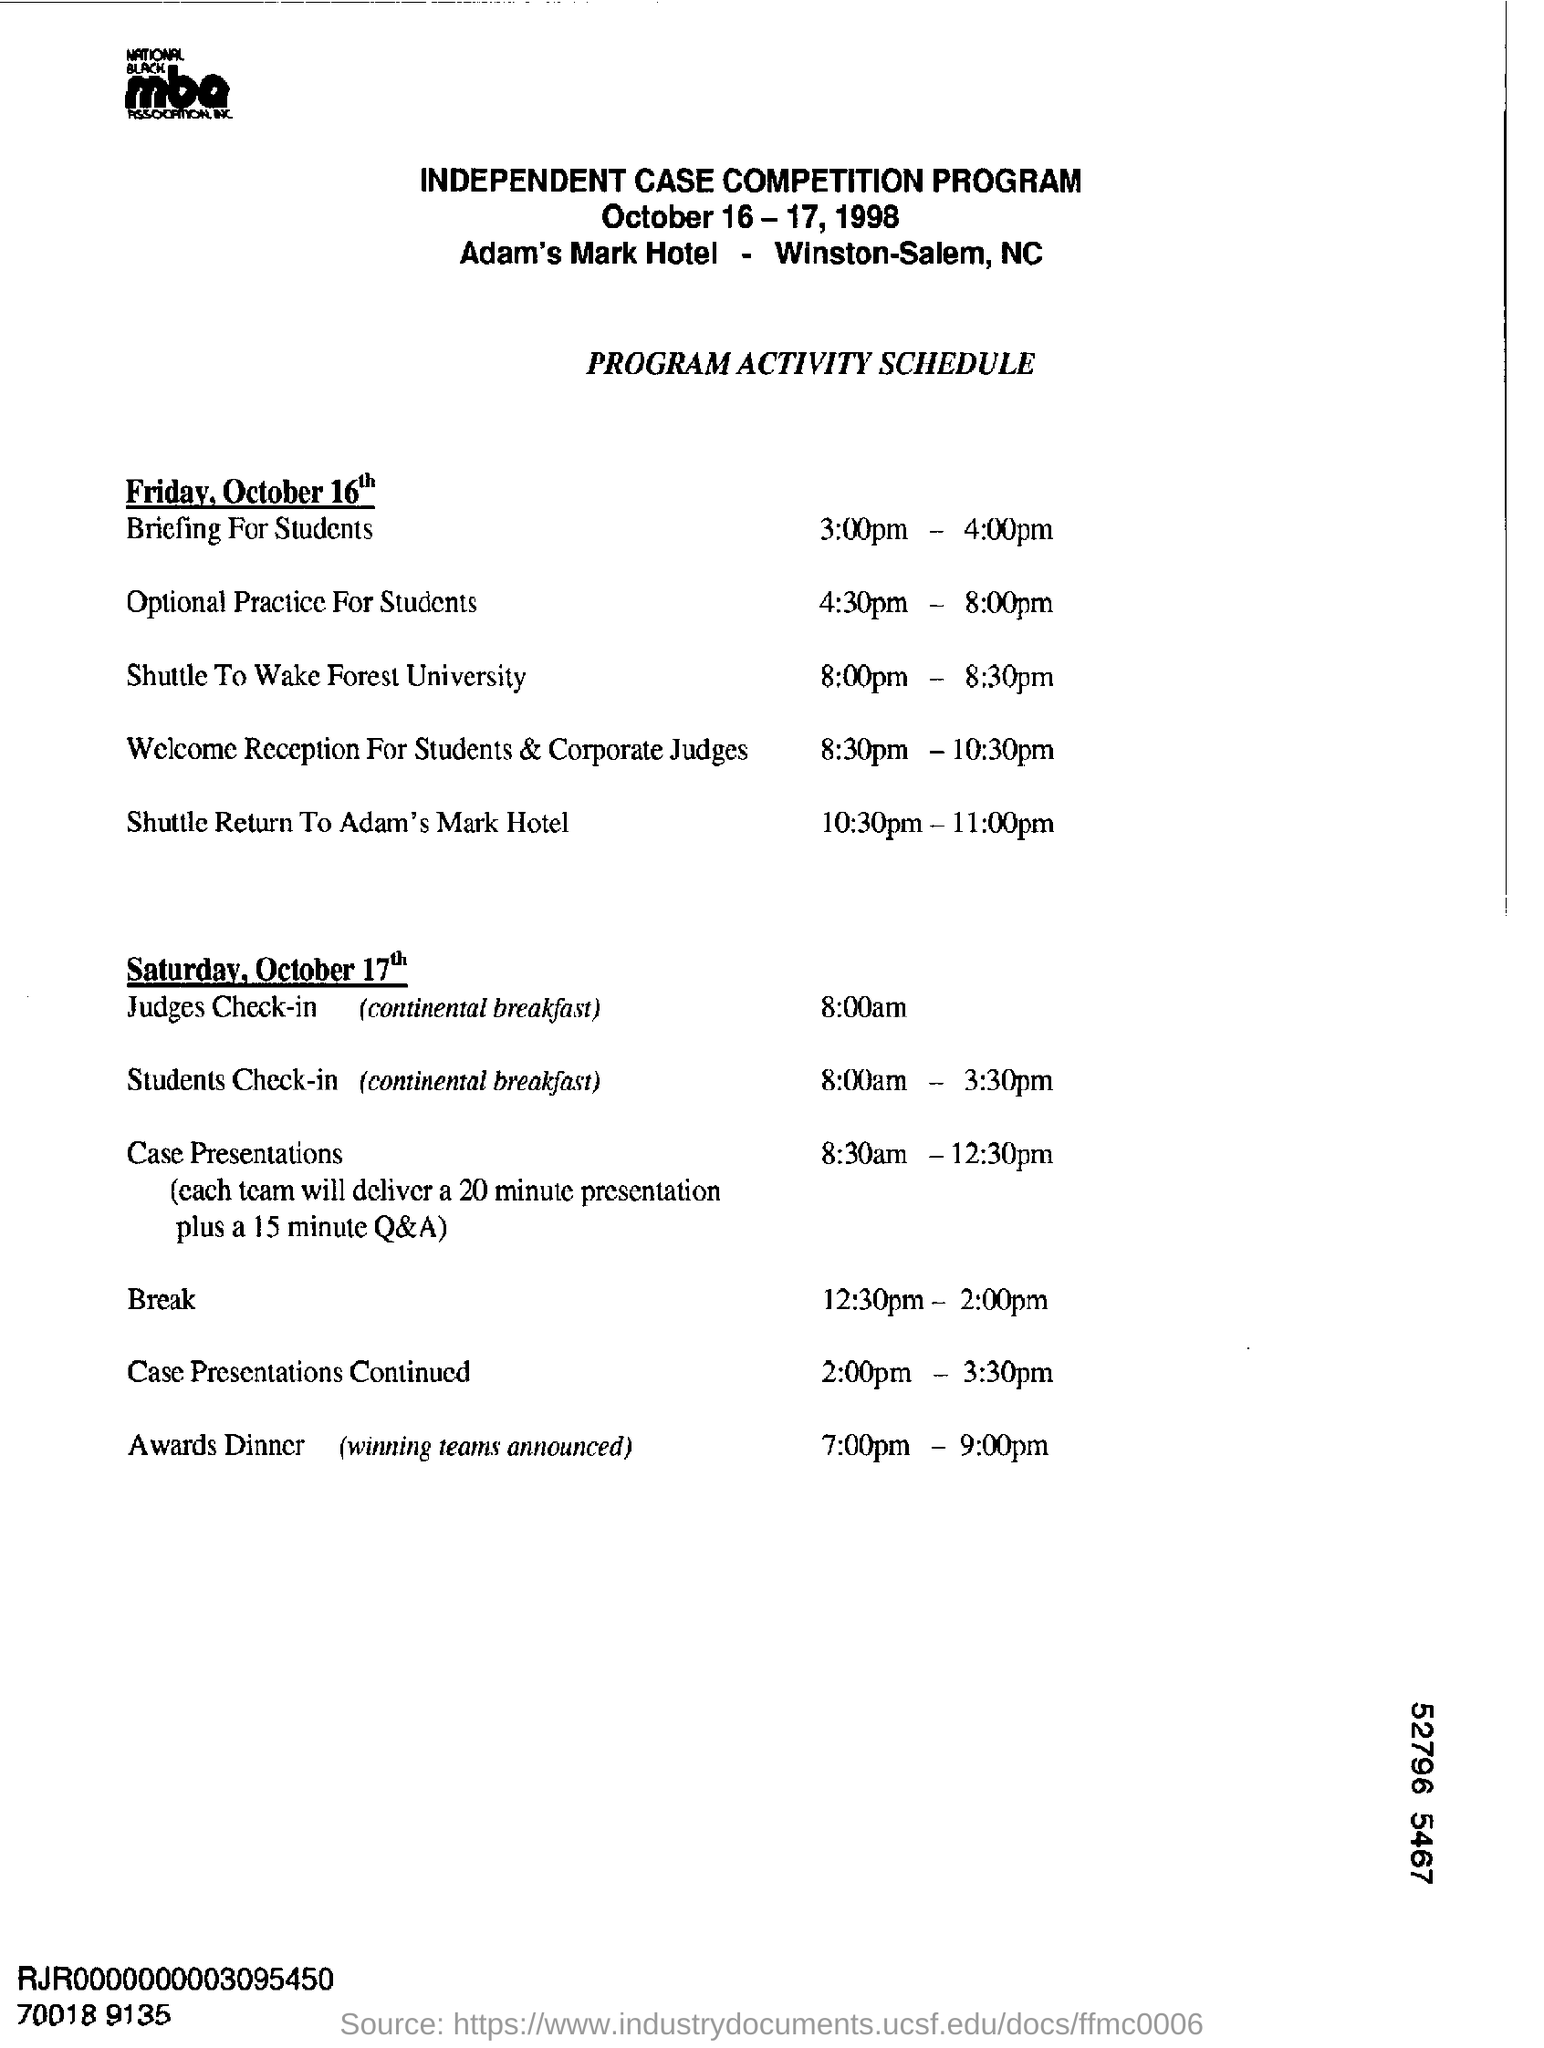What is the name of competition program?
Offer a very short reply. Independent case competition program. In which hotel independent case competition program was held?
Your response must be concise. Adam's Mark Hotel. On which day case presentations are held?
Make the answer very short. Saturday, October 17th. 